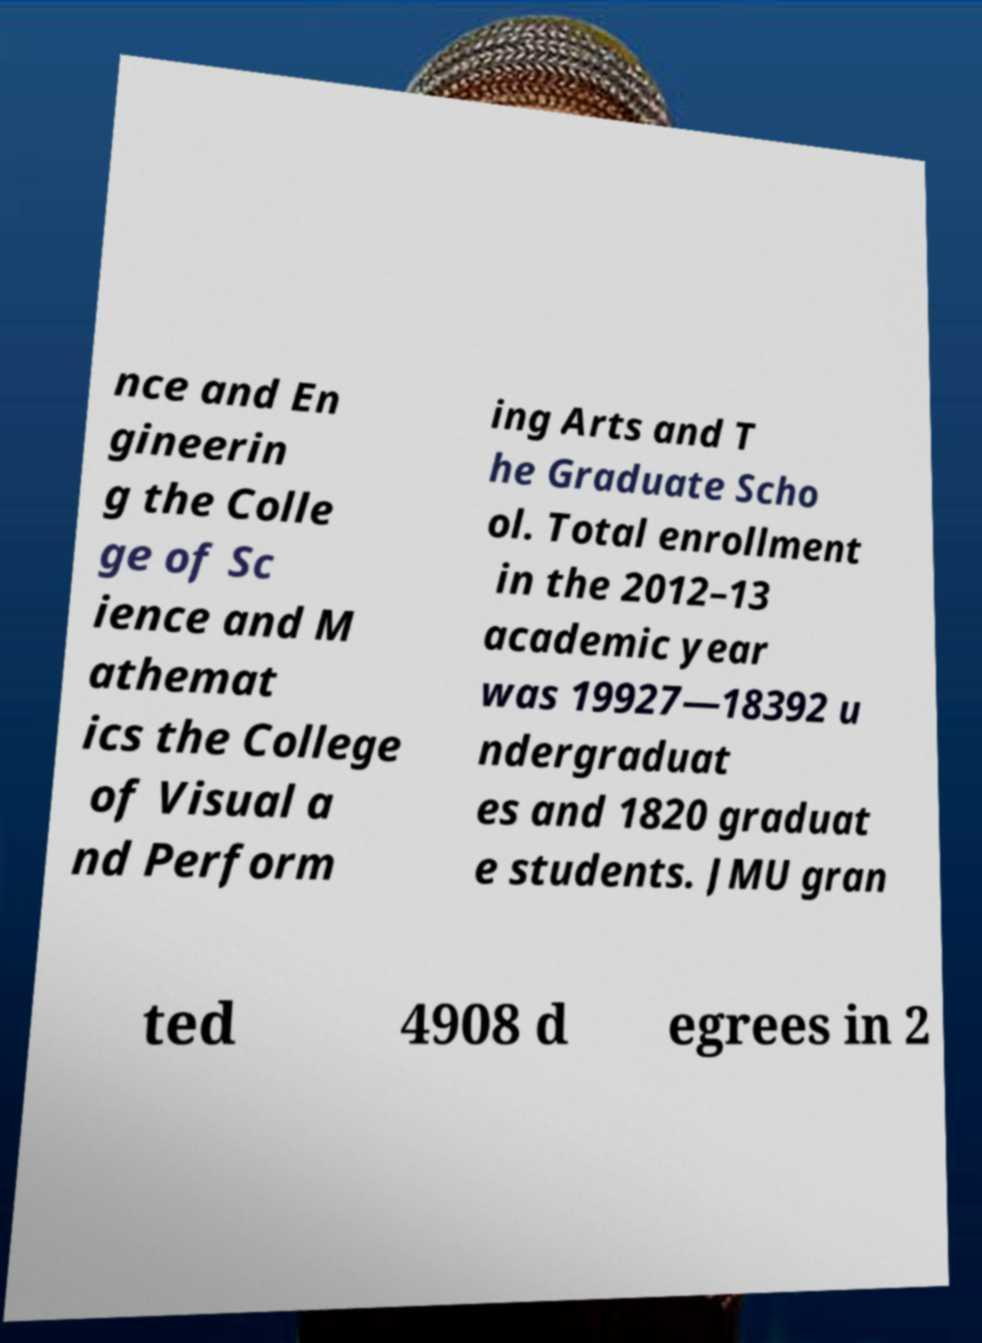Please identify and transcribe the text found in this image. nce and En gineerin g the Colle ge of Sc ience and M athemat ics the College of Visual a nd Perform ing Arts and T he Graduate Scho ol. Total enrollment in the 2012–13 academic year was 19927—18392 u ndergraduat es and 1820 graduat e students. JMU gran ted 4908 d egrees in 2 